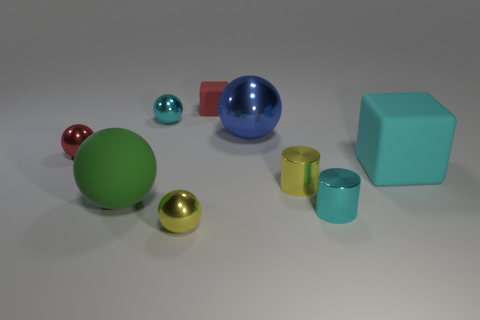Subtract 2 spheres. How many spheres are left? 3 Subtract all tiny red metal balls. How many balls are left? 4 Subtract all cyan balls. How many balls are left? 4 Subtract all brown balls. Subtract all purple cubes. How many balls are left? 5 Add 1 small matte cubes. How many objects exist? 10 Subtract all blocks. How many objects are left? 7 Add 2 tiny red rubber cylinders. How many tiny red rubber cylinders exist? 2 Subtract 0 purple blocks. How many objects are left? 9 Subtract all red cubes. Subtract all red cubes. How many objects are left? 7 Add 1 small yellow things. How many small yellow things are left? 3 